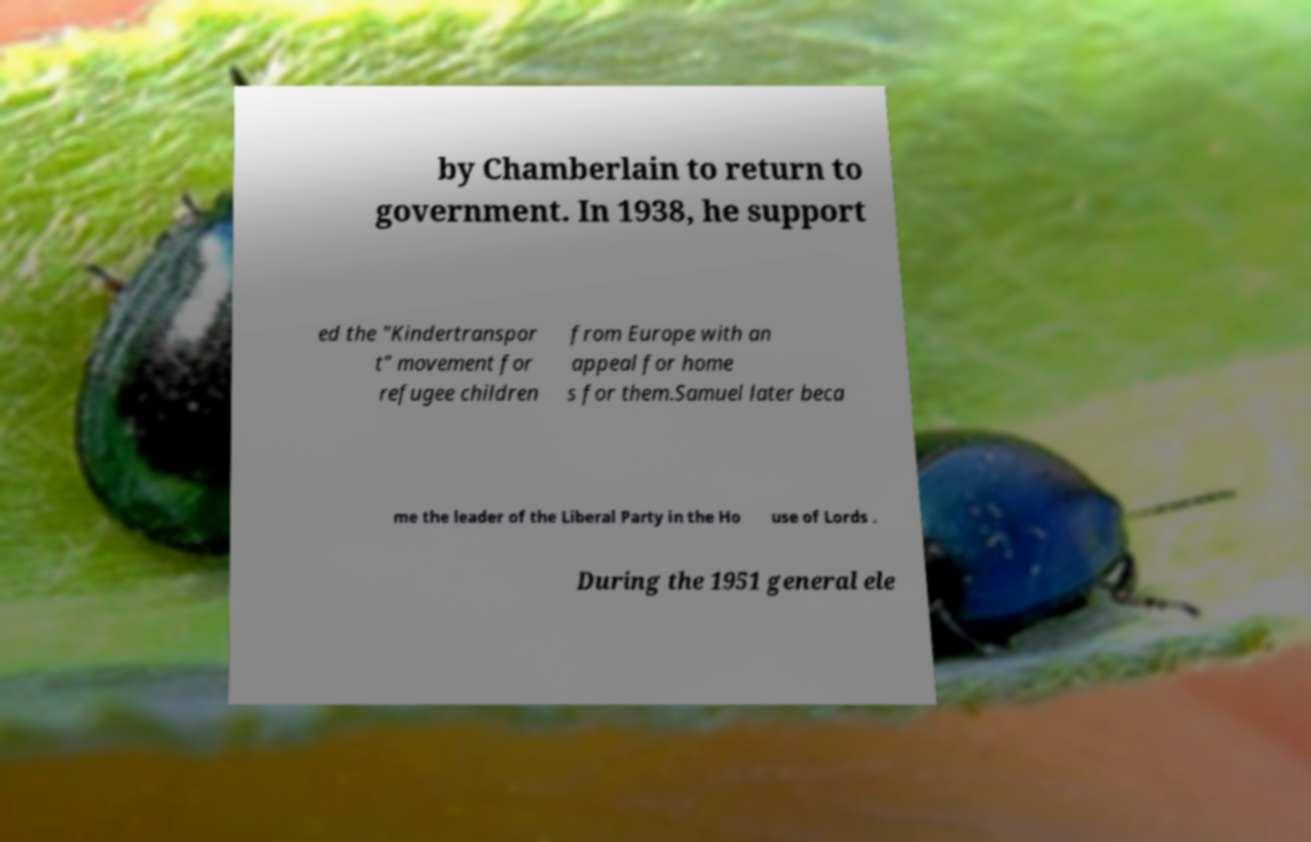I need the written content from this picture converted into text. Can you do that? by Chamberlain to return to government. In 1938, he support ed the "Kindertranspor t" movement for refugee children from Europe with an appeal for home s for them.Samuel later beca me the leader of the Liberal Party in the Ho use of Lords . During the 1951 general ele 